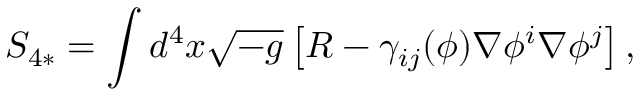<formula> <loc_0><loc_0><loc_500><loc_500>S _ { 4 * } = \int d ^ { 4 } x \sqrt { - g } \left [ R - \gamma _ { i j } ( \phi ) \nabla \phi ^ { i } \nabla \phi ^ { j } \right ] ,</formula> 